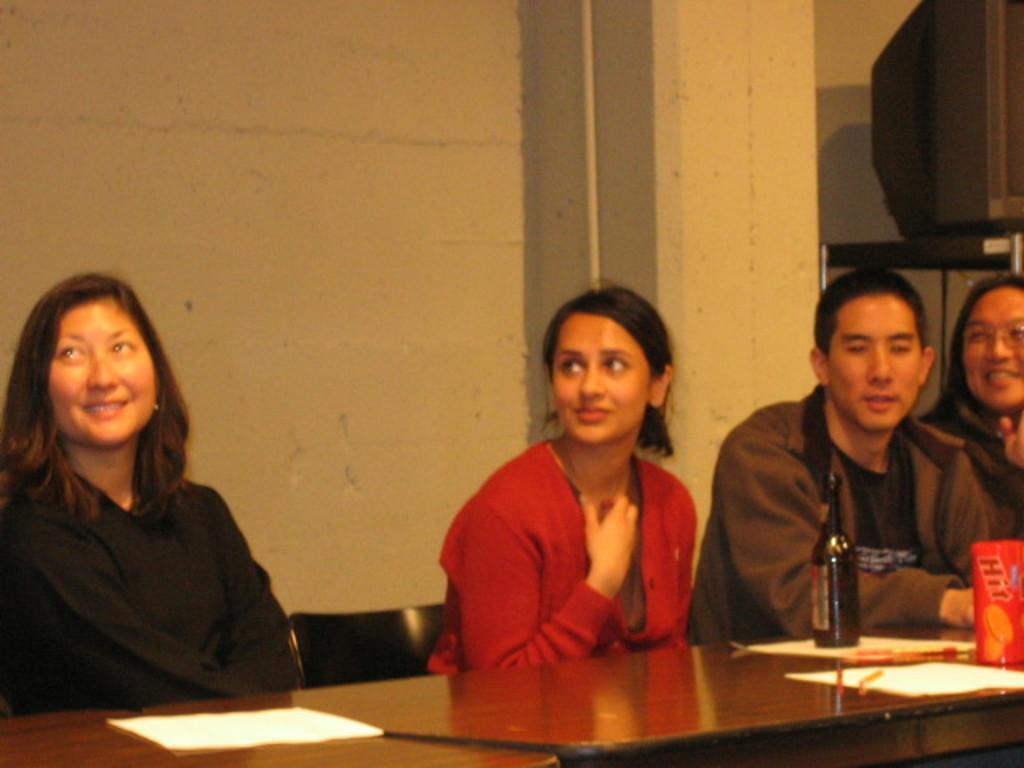How would you summarize this image in a sentence or two? In the picture I can see people sitting in front of a table. On the table I can see a bottle and some other objects. In the background I can see a wall and some other objects. 